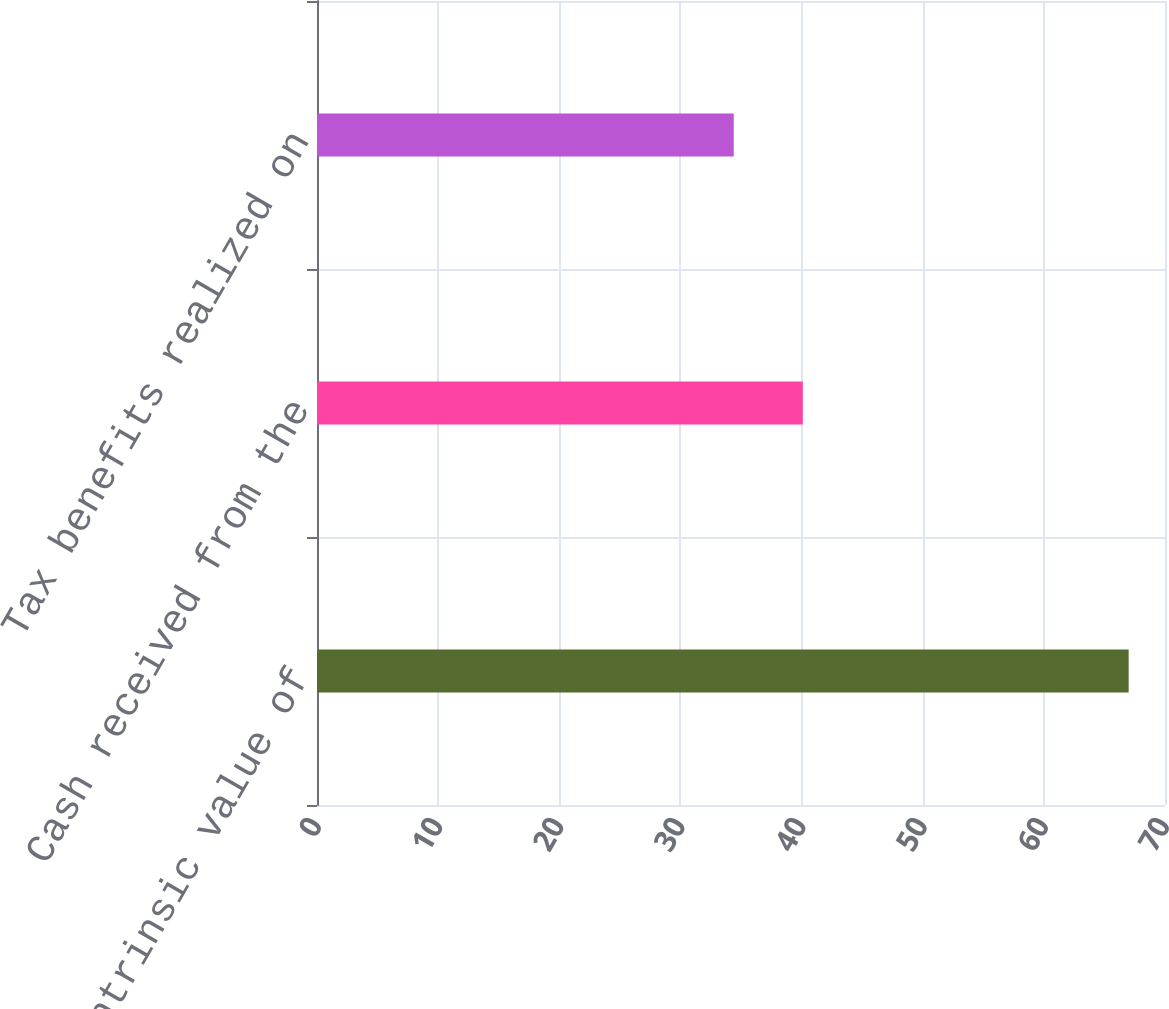Convert chart to OTSL. <chart><loc_0><loc_0><loc_500><loc_500><bar_chart><fcel>Aggregate intrinsic value of<fcel>Cash received from the<fcel>Tax benefits realized on<nl><fcel>67<fcel>40.1<fcel>34.4<nl></chart> 